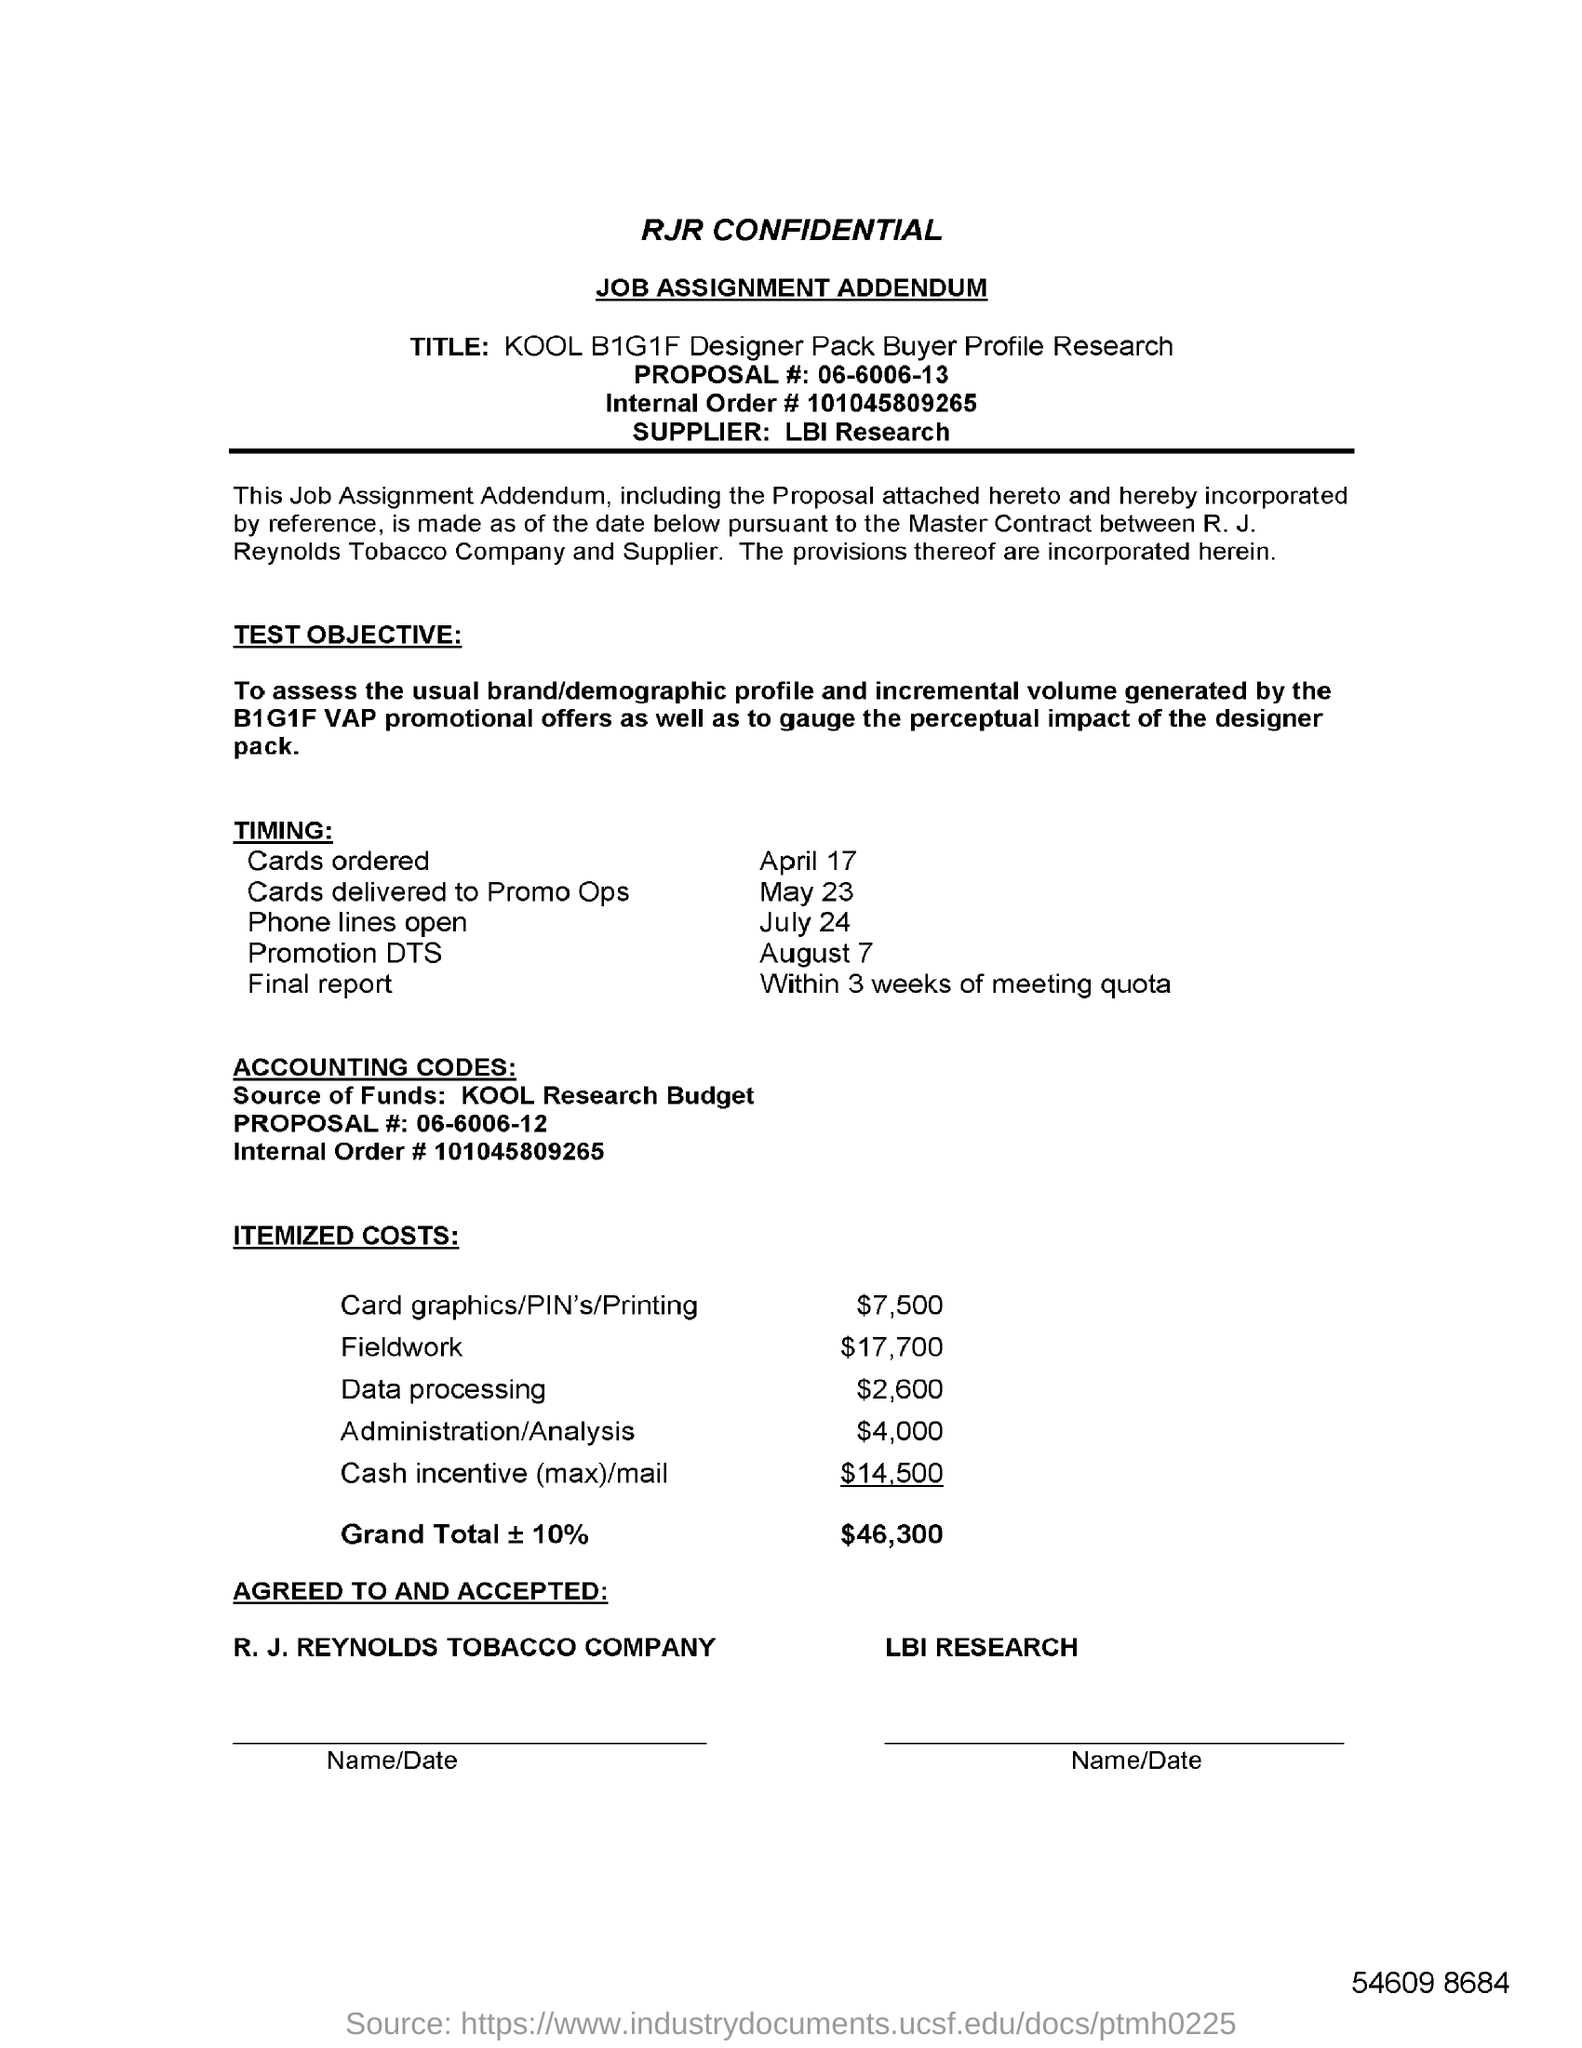What is the Proposal # ?
Offer a terse response. 06-6006-13. Who is the supplier?
Provide a short and direct response. LBI Research. What is the "Timing" for "Promotion DTS"?
Offer a terse response. August 7. What is the Itemized Costs for Field Work?
Give a very brief answer. $17,700. What is the Internal Order # ?
Your response must be concise. 101045809265. What is the "Itemized Costs" for "Data Processing"?
Make the answer very short. 2,600. What is the "Timing" for "Cards Ordered"?
Ensure brevity in your answer.  April 17. What is the "Timing" for "Phone Lines Open"?
Make the answer very short. July 24. 